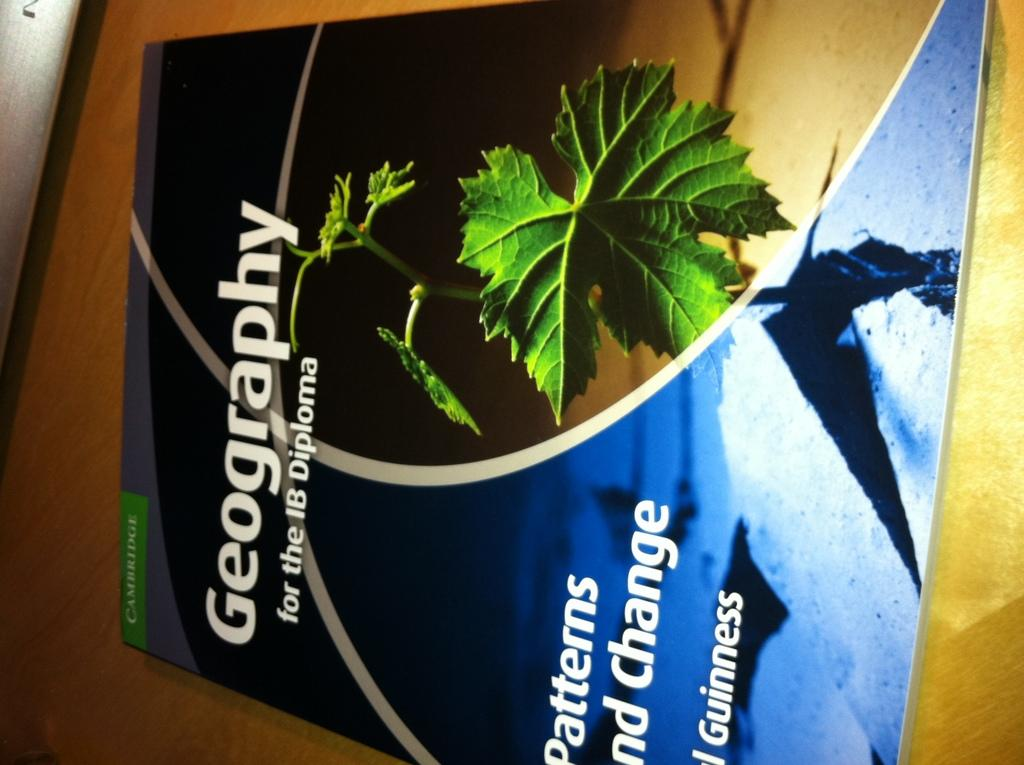<image>
Create a compact narrative representing the image presented. A Text book on Geography patterns and changes. 